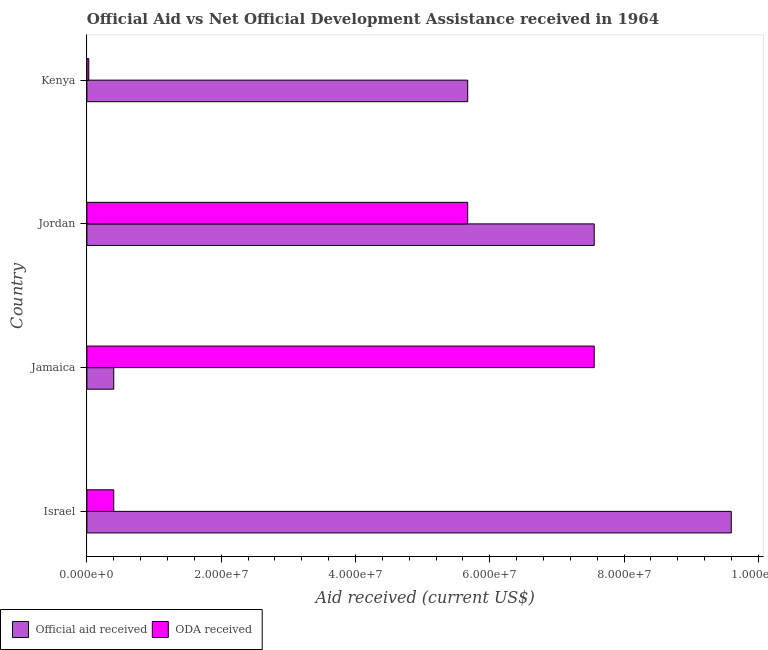How many groups of bars are there?
Your response must be concise. 4. Are the number of bars on each tick of the Y-axis equal?
Keep it short and to the point. Yes. How many bars are there on the 3rd tick from the top?
Offer a very short reply. 2. What is the label of the 1st group of bars from the top?
Your answer should be compact. Kenya. What is the official aid received in Jordan?
Provide a short and direct response. 7.56e+07. Across all countries, what is the maximum official aid received?
Make the answer very short. 9.60e+07. Across all countries, what is the minimum oda received?
Keep it short and to the point. 2.80e+05. In which country was the oda received maximum?
Provide a short and direct response. Jamaica. In which country was the official aid received minimum?
Offer a terse response. Jamaica. What is the total official aid received in the graph?
Offer a terse response. 2.32e+08. What is the difference between the official aid received in Jamaica and that in Jordan?
Provide a succinct answer. -7.16e+07. What is the difference between the oda received in Israel and the official aid received in Jordan?
Ensure brevity in your answer.  -7.16e+07. What is the average official aid received per country?
Provide a short and direct response. 5.81e+07. What is the difference between the oda received and official aid received in Jordan?
Provide a succinct answer. -1.88e+07. In how many countries, is the oda received greater than 88000000 US$?
Give a very brief answer. 0. What is the ratio of the official aid received in Jamaica to that in Kenya?
Make the answer very short. 0.07. What is the difference between the highest and the second highest oda received?
Your answer should be very brief. 1.88e+07. What is the difference between the highest and the lowest oda received?
Your answer should be very brief. 7.53e+07. In how many countries, is the oda received greater than the average oda received taken over all countries?
Offer a terse response. 2. What does the 2nd bar from the top in Jamaica represents?
Your answer should be very brief. Official aid received. What does the 2nd bar from the bottom in Jamaica represents?
Give a very brief answer. ODA received. How many bars are there?
Offer a terse response. 8. Are all the bars in the graph horizontal?
Provide a succinct answer. Yes. What is the difference between two consecutive major ticks on the X-axis?
Your answer should be very brief. 2.00e+07. Are the values on the major ticks of X-axis written in scientific E-notation?
Keep it short and to the point. Yes. Does the graph contain any zero values?
Keep it short and to the point. No. Where does the legend appear in the graph?
Keep it short and to the point. Bottom left. How many legend labels are there?
Make the answer very short. 2. How are the legend labels stacked?
Keep it short and to the point. Horizontal. What is the title of the graph?
Your response must be concise. Official Aid vs Net Official Development Assistance received in 1964 . What is the label or title of the X-axis?
Give a very brief answer. Aid received (current US$). What is the Aid received (current US$) in Official aid received in Israel?
Offer a terse response. 9.60e+07. What is the Aid received (current US$) in ODA received in Israel?
Keep it short and to the point. 4.00e+06. What is the Aid received (current US$) in Official aid received in Jamaica?
Offer a very short reply. 4.00e+06. What is the Aid received (current US$) of ODA received in Jamaica?
Your answer should be compact. 7.56e+07. What is the Aid received (current US$) in Official aid received in Jordan?
Your answer should be very brief. 7.56e+07. What is the Aid received (current US$) in ODA received in Jordan?
Give a very brief answer. 5.67e+07. What is the Aid received (current US$) in Official aid received in Kenya?
Provide a succinct answer. 5.67e+07. What is the Aid received (current US$) in ODA received in Kenya?
Your response must be concise. 2.80e+05. Across all countries, what is the maximum Aid received (current US$) in Official aid received?
Ensure brevity in your answer.  9.60e+07. Across all countries, what is the maximum Aid received (current US$) in ODA received?
Keep it short and to the point. 7.56e+07. Across all countries, what is the minimum Aid received (current US$) of ODA received?
Give a very brief answer. 2.80e+05. What is the total Aid received (current US$) of Official aid received in the graph?
Your answer should be compact. 2.32e+08. What is the total Aid received (current US$) of ODA received in the graph?
Your response must be concise. 1.37e+08. What is the difference between the Aid received (current US$) of Official aid received in Israel and that in Jamaica?
Ensure brevity in your answer.  9.20e+07. What is the difference between the Aid received (current US$) of ODA received in Israel and that in Jamaica?
Give a very brief answer. -7.16e+07. What is the difference between the Aid received (current US$) in Official aid received in Israel and that in Jordan?
Your answer should be compact. 2.04e+07. What is the difference between the Aid received (current US$) of ODA received in Israel and that in Jordan?
Make the answer very short. -5.27e+07. What is the difference between the Aid received (current US$) of Official aid received in Israel and that in Kenya?
Give a very brief answer. 3.92e+07. What is the difference between the Aid received (current US$) in ODA received in Israel and that in Kenya?
Keep it short and to the point. 3.72e+06. What is the difference between the Aid received (current US$) in Official aid received in Jamaica and that in Jordan?
Your answer should be compact. -7.16e+07. What is the difference between the Aid received (current US$) in ODA received in Jamaica and that in Jordan?
Provide a succinct answer. 1.88e+07. What is the difference between the Aid received (current US$) in Official aid received in Jamaica and that in Kenya?
Provide a short and direct response. -5.27e+07. What is the difference between the Aid received (current US$) of ODA received in Jamaica and that in Kenya?
Give a very brief answer. 7.53e+07. What is the difference between the Aid received (current US$) of Official aid received in Jordan and that in Kenya?
Offer a very short reply. 1.88e+07. What is the difference between the Aid received (current US$) of ODA received in Jordan and that in Kenya?
Make the answer very short. 5.64e+07. What is the difference between the Aid received (current US$) in Official aid received in Israel and the Aid received (current US$) in ODA received in Jamaica?
Your answer should be very brief. 2.04e+07. What is the difference between the Aid received (current US$) in Official aid received in Israel and the Aid received (current US$) in ODA received in Jordan?
Provide a succinct answer. 3.92e+07. What is the difference between the Aid received (current US$) in Official aid received in Israel and the Aid received (current US$) in ODA received in Kenya?
Provide a short and direct response. 9.57e+07. What is the difference between the Aid received (current US$) in Official aid received in Jamaica and the Aid received (current US$) in ODA received in Jordan?
Give a very brief answer. -5.27e+07. What is the difference between the Aid received (current US$) in Official aid received in Jamaica and the Aid received (current US$) in ODA received in Kenya?
Make the answer very short. 3.72e+06. What is the difference between the Aid received (current US$) in Official aid received in Jordan and the Aid received (current US$) in ODA received in Kenya?
Your response must be concise. 7.53e+07. What is the average Aid received (current US$) in Official aid received per country?
Give a very brief answer. 5.81e+07. What is the average Aid received (current US$) of ODA received per country?
Offer a terse response. 3.41e+07. What is the difference between the Aid received (current US$) in Official aid received and Aid received (current US$) in ODA received in Israel?
Offer a very short reply. 9.20e+07. What is the difference between the Aid received (current US$) in Official aid received and Aid received (current US$) in ODA received in Jamaica?
Your answer should be compact. -7.16e+07. What is the difference between the Aid received (current US$) in Official aid received and Aid received (current US$) in ODA received in Jordan?
Your answer should be compact. 1.88e+07. What is the difference between the Aid received (current US$) of Official aid received and Aid received (current US$) of ODA received in Kenya?
Make the answer very short. 5.64e+07. What is the ratio of the Aid received (current US$) in Official aid received in Israel to that in Jamaica?
Ensure brevity in your answer.  23.99. What is the ratio of the Aid received (current US$) of ODA received in Israel to that in Jamaica?
Provide a succinct answer. 0.05. What is the ratio of the Aid received (current US$) of Official aid received in Israel to that in Jordan?
Keep it short and to the point. 1.27. What is the ratio of the Aid received (current US$) in ODA received in Israel to that in Jordan?
Offer a very short reply. 0.07. What is the ratio of the Aid received (current US$) of Official aid received in Israel to that in Kenya?
Provide a succinct answer. 1.69. What is the ratio of the Aid received (current US$) of ODA received in Israel to that in Kenya?
Ensure brevity in your answer.  14.29. What is the ratio of the Aid received (current US$) in Official aid received in Jamaica to that in Jordan?
Your answer should be very brief. 0.05. What is the ratio of the Aid received (current US$) in ODA received in Jamaica to that in Jordan?
Your answer should be very brief. 1.33. What is the ratio of the Aid received (current US$) in Official aid received in Jamaica to that in Kenya?
Give a very brief answer. 0.07. What is the ratio of the Aid received (current US$) of ODA received in Jamaica to that in Kenya?
Provide a short and direct response. 269.82. What is the ratio of the Aid received (current US$) in Official aid received in Jordan to that in Kenya?
Ensure brevity in your answer.  1.33. What is the ratio of the Aid received (current US$) of ODA received in Jordan to that in Kenya?
Your answer should be very brief. 202.54. What is the difference between the highest and the second highest Aid received (current US$) of Official aid received?
Your answer should be very brief. 2.04e+07. What is the difference between the highest and the second highest Aid received (current US$) in ODA received?
Provide a short and direct response. 1.88e+07. What is the difference between the highest and the lowest Aid received (current US$) of Official aid received?
Offer a terse response. 9.20e+07. What is the difference between the highest and the lowest Aid received (current US$) of ODA received?
Keep it short and to the point. 7.53e+07. 